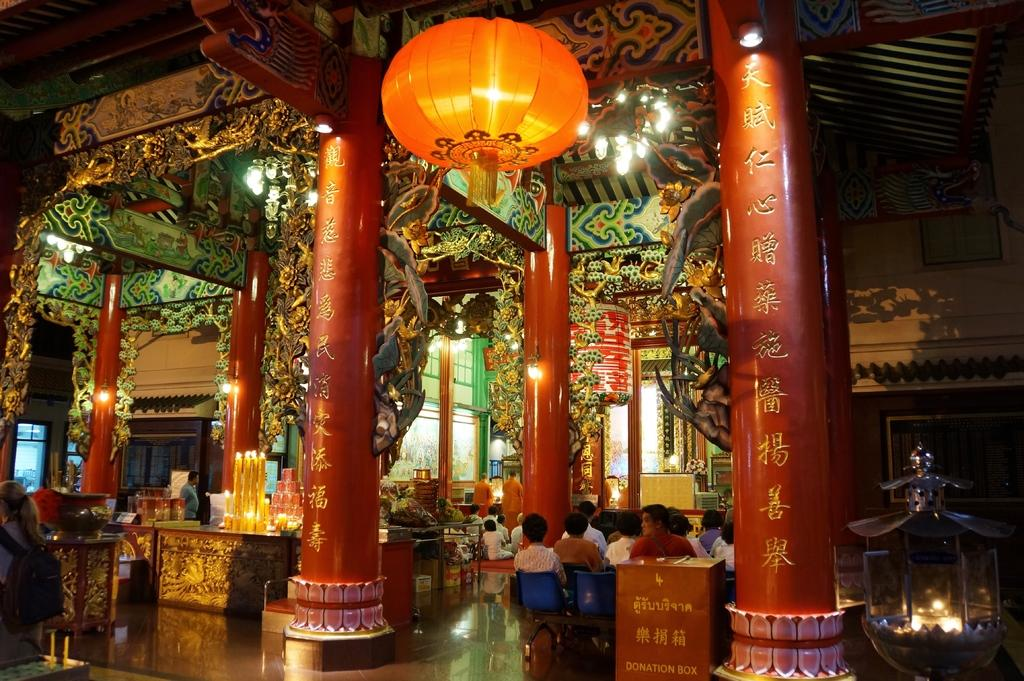What type of architectural feature can be seen in the image? There are pillars in the image. What can be used for illumination in the image? There are lights in the image. What objects are placed on tables in the image? There are objects on tables in the image, but the specific objects are not mentioned in the facts. What are the people in the image doing? There are people sitting on chairs in the image. What type of structure is present in the image? There is a wall in the image. How would you describe the overall appearance of the background in the image? The background of the image is colorful. What type of sand can be seen in the mouth of the person in the image? There is no person with sand in their mouth present in the image. What form does the mouth of the person in the image take? There is no person present in the image, so their mouth cannot be described. 